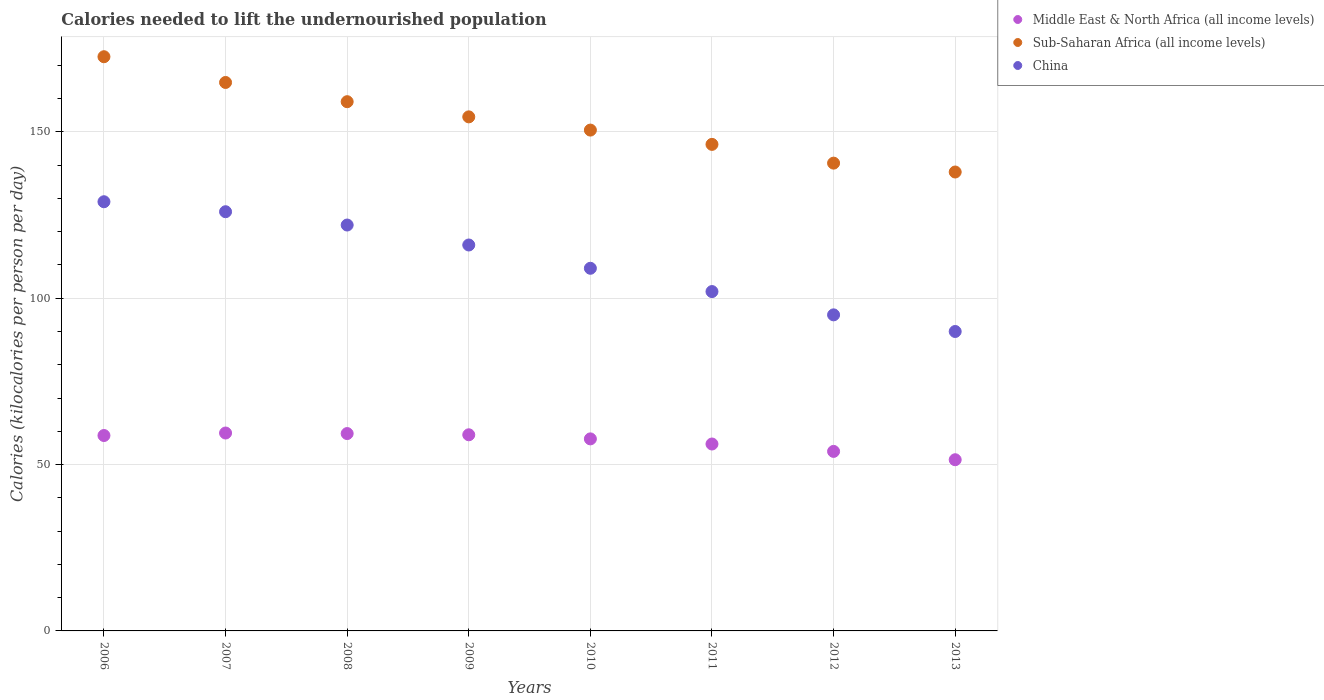How many different coloured dotlines are there?
Provide a short and direct response. 3. What is the total calories needed to lift the undernourished population in Sub-Saharan Africa (all income levels) in 2009?
Keep it short and to the point. 154.51. Across all years, what is the maximum total calories needed to lift the undernourished population in China?
Give a very brief answer. 129. Across all years, what is the minimum total calories needed to lift the undernourished population in Sub-Saharan Africa (all income levels)?
Offer a very short reply. 137.94. In which year was the total calories needed to lift the undernourished population in China maximum?
Provide a succinct answer. 2006. In which year was the total calories needed to lift the undernourished population in Middle East & North Africa (all income levels) minimum?
Your answer should be very brief. 2013. What is the total total calories needed to lift the undernourished population in Middle East & North Africa (all income levels) in the graph?
Ensure brevity in your answer.  455.81. What is the difference between the total calories needed to lift the undernourished population in Middle East & North Africa (all income levels) in 2007 and that in 2012?
Provide a short and direct response. 5.52. What is the difference between the total calories needed to lift the undernourished population in Middle East & North Africa (all income levels) in 2011 and the total calories needed to lift the undernourished population in Sub-Saharan Africa (all income levels) in 2012?
Give a very brief answer. -84.42. What is the average total calories needed to lift the undernourished population in Middle East & North Africa (all income levels) per year?
Your answer should be compact. 56.98. In the year 2011, what is the difference between the total calories needed to lift the undernourished population in Middle East & North Africa (all income levels) and total calories needed to lift the undernourished population in Sub-Saharan Africa (all income levels)?
Offer a very short reply. -90.06. In how many years, is the total calories needed to lift the undernourished population in Middle East & North Africa (all income levels) greater than 140 kilocalories?
Make the answer very short. 0. What is the ratio of the total calories needed to lift the undernourished population in China in 2007 to that in 2012?
Make the answer very short. 1.33. Is the total calories needed to lift the undernourished population in Sub-Saharan Africa (all income levels) in 2007 less than that in 2013?
Offer a very short reply. No. What is the difference between the highest and the second highest total calories needed to lift the undernourished population in Middle East & North Africa (all income levels)?
Your answer should be compact. 0.16. What is the difference between the highest and the lowest total calories needed to lift the undernourished population in China?
Ensure brevity in your answer.  39. In how many years, is the total calories needed to lift the undernourished population in Sub-Saharan Africa (all income levels) greater than the average total calories needed to lift the undernourished population in Sub-Saharan Africa (all income levels) taken over all years?
Ensure brevity in your answer.  4. Is the sum of the total calories needed to lift the undernourished population in Sub-Saharan Africa (all income levels) in 2006 and 2007 greater than the maximum total calories needed to lift the undernourished population in China across all years?
Your answer should be very brief. Yes. Does the total calories needed to lift the undernourished population in Sub-Saharan Africa (all income levels) monotonically increase over the years?
Keep it short and to the point. No. Does the graph contain grids?
Your answer should be very brief. Yes. How are the legend labels stacked?
Offer a terse response. Vertical. What is the title of the graph?
Ensure brevity in your answer.  Calories needed to lift the undernourished population. Does "Belgium" appear as one of the legend labels in the graph?
Your answer should be compact. No. What is the label or title of the X-axis?
Provide a succinct answer. Years. What is the label or title of the Y-axis?
Provide a short and direct response. Calories (kilocalories per person per day). What is the Calories (kilocalories per person per day) in Middle East & North Africa (all income levels) in 2006?
Your response must be concise. 58.73. What is the Calories (kilocalories per person per day) of Sub-Saharan Africa (all income levels) in 2006?
Ensure brevity in your answer.  172.59. What is the Calories (kilocalories per person per day) in China in 2006?
Your answer should be compact. 129. What is the Calories (kilocalories per person per day) in Middle East & North Africa (all income levels) in 2007?
Give a very brief answer. 59.48. What is the Calories (kilocalories per person per day) in Sub-Saharan Africa (all income levels) in 2007?
Your answer should be compact. 164.85. What is the Calories (kilocalories per person per day) of China in 2007?
Keep it short and to the point. 126. What is the Calories (kilocalories per person per day) of Middle East & North Africa (all income levels) in 2008?
Ensure brevity in your answer.  59.32. What is the Calories (kilocalories per person per day) in Sub-Saharan Africa (all income levels) in 2008?
Your answer should be compact. 159.07. What is the Calories (kilocalories per person per day) of China in 2008?
Offer a terse response. 122. What is the Calories (kilocalories per person per day) of Middle East & North Africa (all income levels) in 2009?
Provide a succinct answer. 58.95. What is the Calories (kilocalories per person per day) of Sub-Saharan Africa (all income levels) in 2009?
Your response must be concise. 154.51. What is the Calories (kilocalories per person per day) in China in 2009?
Your answer should be compact. 116. What is the Calories (kilocalories per person per day) in Middle East & North Africa (all income levels) in 2010?
Your answer should be very brief. 57.72. What is the Calories (kilocalories per person per day) in Sub-Saharan Africa (all income levels) in 2010?
Ensure brevity in your answer.  150.54. What is the Calories (kilocalories per person per day) in China in 2010?
Your answer should be very brief. 109. What is the Calories (kilocalories per person per day) of Middle East & North Africa (all income levels) in 2011?
Offer a very short reply. 56.18. What is the Calories (kilocalories per person per day) of Sub-Saharan Africa (all income levels) in 2011?
Offer a very short reply. 146.24. What is the Calories (kilocalories per person per day) of China in 2011?
Give a very brief answer. 102. What is the Calories (kilocalories per person per day) in Middle East & North Africa (all income levels) in 2012?
Provide a short and direct response. 53.96. What is the Calories (kilocalories per person per day) of Sub-Saharan Africa (all income levels) in 2012?
Make the answer very short. 140.6. What is the Calories (kilocalories per person per day) in China in 2012?
Your answer should be compact. 95. What is the Calories (kilocalories per person per day) of Middle East & North Africa (all income levels) in 2013?
Your response must be concise. 51.45. What is the Calories (kilocalories per person per day) of Sub-Saharan Africa (all income levels) in 2013?
Provide a succinct answer. 137.94. Across all years, what is the maximum Calories (kilocalories per person per day) in Middle East & North Africa (all income levels)?
Keep it short and to the point. 59.48. Across all years, what is the maximum Calories (kilocalories per person per day) in Sub-Saharan Africa (all income levels)?
Your response must be concise. 172.59. Across all years, what is the maximum Calories (kilocalories per person per day) of China?
Provide a short and direct response. 129. Across all years, what is the minimum Calories (kilocalories per person per day) of Middle East & North Africa (all income levels)?
Offer a terse response. 51.45. Across all years, what is the minimum Calories (kilocalories per person per day) in Sub-Saharan Africa (all income levels)?
Offer a very short reply. 137.94. What is the total Calories (kilocalories per person per day) of Middle East & North Africa (all income levels) in the graph?
Keep it short and to the point. 455.81. What is the total Calories (kilocalories per person per day) in Sub-Saharan Africa (all income levels) in the graph?
Your response must be concise. 1226.33. What is the total Calories (kilocalories per person per day) of China in the graph?
Your answer should be compact. 889. What is the difference between the Calories (kilocalories per person per day) in Middle East & North Africa (all income levels) in 2006 and that in 2007?
Your response must be concise. -0.75. What is the difference between the Calories (kilocalories per person per day) of Sub-Saharan Africa (all income levels) in 2006 and that in 2007?
Make the answer very short. 7.74. What is the difference between the Calories (kilocalories per person per day) of China in 2006 and that in 2007?
Keep it short and to the point. 3. What is the difference between the Calories (kilocalories per person per day) in Middle East & North Africa (all income levels) in 2006 and that in 2008?
Provide a short and direct response. -0.59. What is the difference between the Calories (kilocalories per person per day) in Sub-Saharan Africa (all income levels) in 2006 and that in 2008?
Make the answer very short. 13.52. What is the difference between the Calories (kilocalories per person per day) of Middle East & North Africa (all income levels) in 2006 and that in 2009?
Give a very brief answer. -0.22. What is the difference between the Calories (kilocalories per person per day) in Sub-Saharan Africa (all income levels) in 2006 and that in 2009?
Ensure brevity in your answer.  18.08. What is the difference between the Calories (kilocalories per person per day) of Middle East & North Africa (all income levels) in 2006 and that in 2010?
Ensure brevity in your answer.  1.01. What is the difference between the Calories (kilocalories per person per day) in Sub-Saharan Africa (all income levels) in 2006 and that in 2010?
Offer a terse response. 22.05. What is the difference between the Calories (kilocalories per person per day) in China in 2006 and that in 2010?
Keep it short and to the point. 20. What is the difference between the Calories (kilocalories per person per day) in Middle East & North Africa (all income levels) in 2006 and that in 2011?
Provide a succinct answer. 2.55. What is the difference between the Calories (kilocalories per person per day) in Sub-Saharan Africa (all income levels) in 2006 and that in 2011?
Provide a short and direct response. 26.35. What is the difference between the Calories (kilocalories per person per day) of China in 2006 and that in 2011?
Offer a very short reply. 27. What is the difference between the Calories (kilocalories per person per day) of Middle East & North Africa (all income levels) in 2006 and that in 2012?
Make the answer very short. 4.77. What is the difference between the Calories (kilocalories per person per day) of Sub-Saharan Africa (all income levels) in 2006 and that in 2012?
Give a very brief answer. 31.98. What is the difference between the Calories (kilocalories per person per day) in China in 2006 and that in 2012?
Give a very brief answer. 34. What is the difference between the Calories (kilocalories per person per day) of Middle East & North Africa (all income levels) in 2006 and that in 2013?
Provide a succinct answer. 7.28. What is the difference between the Calories (kilocalories per person per day) in Sub-Saharan Africa (all income levels) in 2006 and that in 2013?
Your answer should be very brief. 34.65. What is the difference between the Calories (kilocalories per person per day) of China in 2006 and that in 2013?
Offer a terse response. 39. What is the difference between the Calories (kilocalories per person per day) of Middle East & North Africa (all income levels) in 2007 and that in 2008?
Make the answer very short. 0.16. What is the difference between the Calories (kilocalories per person per day) of Sub-Saharan Africa (all income levels) in 2007 and that in 2008?
Keep it short and to the point. 5.78. What is the difference between the Calories (kilocalories per person per day) in Middle East & North Africa (all income levels) in 2007 and that in 2009?
Offer a terse response. 0.53. What is the difference between the Calories (kilocalories per person per day) of Sub-Saharan Africa (all income levels) in 2007 and that in 2009?
Offer a very short reply. 10.34. What is the difference between the Calories (kilocalories per person per day) in China in 2007 and that in 2009?
Your response must be concise. 10. What is the difference between the Calories (kilocalories per person per day) in Middle East & North Africa (all income levels) in 2007 and that in 2010?
Offer a terse response. 1.76. What is the difference between the Calories (kilocalories per person per day) of Sub-Saharan Africa (all income levels) in 2007 and that in 2010?
Make the answer very short. 14.31. What is the difference between the Calories (kilocalories per person per day) in China in 2007 and that in 2010?
Provide a succinct answer. 17. What is the difference between the Calories (kilocalories per person per day) of Middle East & North Africa (all income levels) in 2007 and that in 2011?
Your response must be concise. 3.3. What is the difference between the Calories (kilocalories per person per day) in Sub-Saharan Africa (all income levels) in 2007 and that in 2011?
Offer a very short reply. 18.61. What is the difference between the Calories (kilocalories per person per day) of China in 2007 and that in 2011?
Your answer should be compact. 24. What is the difference between the Calories (kilocalories per person per day) of Middle East & North Africa (all income levels) in 2007 and that in 2012?
Make the answer very short. 5.53. What is the difference between the Calories (kilocalories per person per day) in Sub-Saharan Africa (all income levels) in 2007 and that in 2012?
Offer a very short reply. 24.25. What is the difference between the Calories (kilocalories per person per day) of Middle East & North Africa (all income levels) in 2007 and that in 2013?
Make the answer very short. 8.03. What is the difference between the Calories (kilocalories per person per day) in Sub-Saharan Africa (all income levels) in 2007 and that in 2013?
Give a very brief answer. 26.91. What is the difference between the Calories (kilocalories per person per day) of Middle East & North Africa (all income levels) in 2008 and that in 2009?
Your response must be concise. 0.37. What is the difference between the Calories (kilocalories per person per day) of Sub-Saharan Africa (all income levels) in 2008 and that in 2009?
Ensure brevity in your answer.  4.56. What is the difference between the Calories (kilocalories per person per day) of Middle East & North Africa (all income levels) in 2008 and that in 2010?
Offer a terse response. 1.6. What is the difference between the Calories (kilocalories per person per day) of Sub-Saharan Africa (all income levels) in 2008 and that in 2010?
Provide a short and direct response. 8.54. What is the difference between the Calories (kilocalories per person per day) in China in 2008 and that in 2010?
Your response must be concise. 13. What is the difference between the Calories (kilocalories per person per day) in Middle East & North Africa (all income levels) in 2008 and that in 2011?
Make the answer very short. 3.14. What is the difference between the Calories (kilocalories per person per day) in Sub-Saharan Africa (all income levels) in 2008 and that in 2011?
Offer a very short reply. 12.83. What is the difference between the Calories (kilocalories per person per day) of China in 2008 and that in 2011?
Your response must be concise. 20. What is the difference between the Calories (kilocalories per person per day) of Middle East & North Africa (all income levels) in 2008 and that in 2012?
Ensure brevity in your answer.  5.36. What is the difference between the Calories (kilocalories per person per day) in Sub-Saharan Africa (all income levels) in 2008 and that in 2012?
Provide a succinct answer. 18.47. What is the difference between the Calories (kilocalories per person per day) of China in 2008 and that in 2012?
Your response must be concise. 27. What is the difference between the Calories (kilocalories per person per day) in Middle East & North Africa (all income levels) in 2008 and that in 2013?
Offer a very short reply. 7.87. What is the difference between the Calories (kilocalories per person per day) in Sub-Saharan Africa (all income levels) in 2008 and that in 2013?
Ensure brevity in your answer.  21.14. What is the difference between the Calories (kilocalories per person per day) in China in 2008 and that in 2013?
Provide a succinct answer. 32. What is the difference between the Calories (kilocalories per person per day) of Middle East & North Africa (all income levels) in 2009 and that in 2010?
Make the answer very short. 1.23. What is the difference between the Calories (kilocalories per person per day) in Sub-Saharan Africa (all income levels) in 2009 and that in 2010?
Keep it short and to the point. 3.97. What is the difference between the Calories (kilocalories per person per day) of Middle East & North Africa (all income levels) in 2009 and that in 2011?
Offer a terse response. 2.77. What is the difference between the Calories (kilocalories per person per day) in Sub-Saharan Africa (all income levels) in 2009 and that in 2011?
Your answer should be very brief. 8.27. What is the difference between the Calories (kilocalories per person per day) in China in 2009 and that in 2011?
Your answer should be very brief. 14. What is the difference between the Calories (kilocalories per person per day) in Middle East & North Africa (all income levels) in 2009 and that in 2012?
Your answer should be compact. 5. What is the difference between the Calories (kilocalories per person per day) in Sub-Saharan Africa (all income levels) in 2009 and that in 2012?
Offer a terse response. 13.91. What is the difference between the Calories (kilocalories per person per day) in China in 2009 and that in 2012?
Your answer should be very brief. 21. What is the difference between the Calories (kilocalories per person per day) in Middle East & North Africa (all income levels) in 2009 and that in 2013?
Your answer should be compact. 7.5. What is the difference between the Calories (kilocalories per person per day) of Sub-Saharan Africa (all income levels) in 2009 and that in 2013?
Your answer should be very brief. 16.58. What is the difference between the Calories (kilocalories per person per day) of Middle East & North Africa (all income levels) in 2010 and that in 2011?
Ensure brevity in your answer.  1.54. What is the difference between the Calories (kilocalories per person per day) in Sub-Saharan Africa (all income levels) in 2010 and that in 2011?
Your answer should be compact. 4.3. What is the difference between the Calories (kilocalories per person per day) in Middle East & North Africa (all income levels) in 2010 and that in 2012?
Keep it short and to the point. 3.76. What is the difference between the Calories (kilocalories per person per day) of Sub-Saharan Africa (all income levels) in 2010 and that in 2012?
Offer a very short reply. 9.93. What is the difference between the Calories (kilocalories per person per day) in Middle East & North Africa (all income levels) in 2010 and that in 2013?
Make the answer very short. 6.27. What is the difference between the Calories (kilocalories per person per day) in Sub-Saharan Africa (all income levels) in 2010 and that in 2013?
Your response must be concise. 12.6. What is the difference between the Calories (kilocalories per person per day) of Middle East & North Africa (all income levels) in 2011 and that in 2012?
Give a very brief answer. 2.22. What is the difference between the Calories (kilocalories per person per day) of Sub-Saharan Africa (all income levels) in 2011 and that in 2012?
Your answer should be very brief. 5.64. What is the difference between the Calories (kilocalories per person per day) in Middle East & North Africa (all income levels) in 2011 and that in 2013?
Give a very brief answer. 4.73. What is the difference between the Calories (kilocalories per person per day) of Sub-Saharan Africa (all income levels) in 2011 and that in 2013?
Make the answer very short. 8.31. What is the difference between the Calories (kilocalories per person per day) in China in 2011 and that in 2013?
Your response must be concise. 12. What is the difference between the Calories (kilocalories per person per day) in Middle East & North Africa (all income levels) in 2012 and that in 2013?
Keep it short and to the point. 2.5. What is the difference between the Calories (kilocalories per person per day) in Sub-Saharan Africa (all income levels) in 2012 and that in 2013?
Keep it short and to the point. 2.67. What is the difference between the Calories (kilocalories per person per day) in Middle East & North Africa (all income levels) in 2006 and the Calories (kilocalories per person per day) in Sub-Saharan Africa (all income levels) in 2007?
Keep it short and to the point. -106.12. What is the difference between the Calories (kilocalories per person per day) in Middle East & North Africa (all income levels) in 2006 and the Calories (kilocalories per person per day) in China in 2007?
Your response must be concise. -67.27. What is the difference between the Calories (kilocalories per person per day) in Sub-Saharan Africa (all income levels) in 2006 and the Calories (kilocalories per person per day) in China in 2007?
Offer a very short reply. 46.59. What is the difference between the Calories (kilocalories per person per day) in Middle East & North Africa (all income levels) in 2006 and the Calories (kilocalories per person per day) in Sub-Saharan Africa (all income levels) in 2008?
Provide a succinct answer. -100.34. What is the difference between the Calories (kilocalories per person per day) of Middle East & North Africa (all income levels) in 2006 and the Calories (kilocalories per person per day) of China in 2008?
Give a very brief answer. -63.27. What is the difference between the Calories (kilocalories per person per day) in Sub-Saharan Africa (all income levels) in 2006 and the Calories (kilocalories per person per day) in China in 2008?
Ensure brevity in your answer.  50.59. What is the difference between the Calories (kilocalories per person per day) of Middle East & North Africa (all income levels) in 2006 and the Calories (kilocalories per person per day) of Sub-Saharan Africa (all income levels) in 2009?
Your answer should be very brief. -95.78. What is the difference between the Calories (kilocalories per person per day) in Middle East & North Africa (all income levels) in 2006 and the Calories (kilocalories per person per day) in China in 2009?
Make the answer very short. -57.27. What is the difference between the Calories (kilocalories per person per day) in Sub-Saharan Africa (all income levels) in 2006 and the Calories (kilocalories per person per day) in China in 2009?
Keep it short and to the point. 56.59. What is the difference between the Calories (kilocalories per person per day) of Middle East & North Africa (all income levels) in 2006 and the Calories (kilocalories per person per day) of Sub-Saharan Africa (all income levels) in 2010?
Keep it short and to the point. -91.8. What is the difference between the Calories (kilocalories per person per day) in Middle East & North Africa (all income levels) in 2006 and the Calories (kilocalories per person per day) in China in 2010?
Keep it short and to the point. -50.27. What is the difference between the Calories (kilocalories per person per day) of Sub-Saharan Africa (all income levels) in 2006 and the Calories (kilocalories per person per day) of China in 2010?
Your answer should be very brief. 63.59. What is the difference between the Calories (kilocalories per person per day) in Middle East & North Africa (all income levels) in 2006 and the Calories (kilocalories per person per day) in Sub-Saharan Africa (all income levels) in 2011?
Ensure brevity in your answer.  -87.51. What is the difference between the Calories (kilocalories per person per day) in Middle East & North Africa (all income levels) in 2006 and the Calories (kilocalories per person per day) in China in 2011?
Ensure brevity in your answer.  -43.27. What is the difference between the Calories (kilocalories per person per day) in Sub-Saharan Africa (all income levels) in 2006 and the Calories (kilocalories per person per day) in China in 2011?
Your answer should be very brief. 70.59. What is the difference between the Calories (kilocalories per person per day) in Middle East & North Africa (all income levels) in 2006 and the Calories (kilocalories per person per day) in Sub-Saharan Africa (all income levels) in 2012?
Provide a short and direct response. -81.87. What is the difference between the Calories (kilocalories per person per day) in Middle East & North Africa (all income levels) in 2006 and the Calories (kilocalories per person per day) in China in 2012?
Provide a short and direct response. -36.27. What is the difference between the Calories (kilocalories per person per day) of Sub-Saharan Africa (all income levels) in 2006 and the Calories (kilocalories per person per day) of China in 2012?
Make the answer very short. 77.59. What is the difference between the Calories (kilocalories per person per day) in Middle East & North Africa (all income levels) in 2006 and the Calories (kilocalories per person per day) in Sub-Saharan Africa (all income levels) in 2013?
Your answer should be compact. -79.2. What is the difference between the Calories (kilocalories per person per day) in Middle East & North Africa (all income levels) in 2006 and the Calories (kilocalories per person per day) in China in 2013?
Make the answer very short. -31.27. What is the difference between the Calories (kilocalories per person per day) of Sub-Saharan Africa (all income levels) in 2006 and the Calories (kilocalories per person per day) of China in 2013?
Keep it short and to the point. 82.59. What is the difference between the Calories (kilocalories per person per day) of Middle East & North Africa (all income levels) in 2007 and the Calories (kilocalories per person per day) of Sub-Saharan Africa (all income levels) in 2008?
Offer a terse response. -99.59. What is the difference between the Calories (kilocalories per person per day) in Middle East & North Africa (all income levels) in 2007 and the Calories (kilocalories per person per day) in China in 2008?
Keep it short and to the point. -62.52. What is the difference between the Calories (kilocalories per person per day) in Sub-Saharan Africa (all income levels) in 2007 and the Calories (kilocalories per person per day) in China in 2008?
Provide a short and direct response. 42.85. What is the difference between the Calories (kilocalories per person per day) of Middle East & North Africa (all income levels) in 2007 and the Calories (kilocalories per person per day) of Sub-Saharan Africa (all income levels) in 2009?
Keep it short and to the point. -95.03. What is the difference between the Calories (kilocalories per person per day) of Middle East & North Africa (all income levels) in 2007 and the Calories (kilocalories per person per day) of China in 2009?
Your answer should be very brief. -56.52. What is the difference between the Calories (kilocalories per person per day) in Sub-Saharan Africa (all income levels) in 2007 and the Calories (kilocalories per person per day) in China in 2009?
Keep it short and to the point. 48.85. What is the difference between the Calories (kilocalories per person per day) in Middle East & North Africa (all income levels) in 2007 and the Calories (kilocalories per person per day) in Sub-Saharan Africa (all income levels) in 2010?
Provide a short and direct response. -91.05. What is the difference between the Calories (kilocalories per person per day) of Middle East & North Africa (all income levels) in 2007 and the Calories (kilocalories per person per day) of China in 2010?
Keep it short and to the point. -49.52. What is the difference between the Calories (kilocalories per person per day) of Sub-Saharan Africa (all income levels) in 2007 and the Calories (kilocalories per person per day) of China in 2010?
Keep it short and to the point. 55.85. What is the difference between the Calories (kilocalories per person per day) in Middle East & North Africa (all income levels) in 2007 and the Calories (kilocalories per person per day) in Sub-Saharan Africa (all income levels) in 2011?
Your response must be concise. -86.76. What is the difference between the Calories (kilocalories per person per day) of Middle East & North Africa (all income levels) in 2007 and the Calories (kilocalories per person per day) of China in 2011?
Provide a succinct answer. -42.52. What is the difference between the Calories (kilocalories per person per day) of Sub-Saharan Africa (all income levels) in 2007 and the Calories (kilocalories per person per day) of China in 2011?
Provide a short and direct response. 62.85. What is the difference between the Calories (kilocalories per person per day) in Middle East & North Africa (all income levels) in 2007 and the Calories (kilocalories per person per day) in Sub-Saharan Africa (all income levels) in 2012?
Offer a terse response. -81.12. What is the difference between the Calories (kilocalories per person per day) of Middle East & North Africa (all income levels) in 2007 and the Calories (kilocalories per person per day) of China in 2012?
Keep it short and to the point. -35.52. What is the difference between the Calories (kilocalories per person per day) of Sub-Saharan Africa (all income levels) in 2007 and the Calories (kilocalories per person per day) of China in 2012?
Provide a short and direct response. 69.85. What is the difference between the Calories (kilocalories per person per day) in Middle East & North Africa (all income levels) in 2007 and the Calories (kilocalories per person per day) in Sub-Saharan Africa (all income levels) in 2013?
Keep it short and to the point. -78.45. What is the difference between the Calories (kilocalories per person per day) in Middle East & North Africa (all income levels) in 2007 and the Calories (kilocalories per person per day) in China in 2013?
Keep it short and to the point. -30.52. What is the difference between the Calories (kilocalories per person per day) in Sub-Saharan Africa (all income levels) in 2007 and the Calories (kilocalories per person per day) in China in 2013?
Offer a terse response. 74.85. What is the difference between the Calories (kilocalories per person per day) of Middle East & North Africa (all income levels) in 2008 and the Calories (kilocalories per person per day) of Sub-Saharan Africa (all income levels) in 2009?
Offer a very short reply. -95.19. What is the difference between the Calories (kilocalories per person per day) in Middle East & North Africa (all income levels) in 2008 and the Calories (kilocalories per person per day) in China in 2009?
Provide a short and direct response. -56.68. What is the difference between the Calories (kilocalories per person per day) in Sub-Saharan Africa (all income levels) in 2008 and the Calories (kilocalories per person per day) in China in 2009?
Give a very brief answer. 43.07. What is the difference between the Calories (kilocalories per person per day) in Middle East & North Africa (all income levels) in 2008 and the Calories (kilocalories per person per day) in Sub-Saharan Africa (all income levels) in 2010?
Provide a succinct answer. -91.21. What is the difference between the Calories (kilocalories per person per day) in Middle East & North Africa (all income levels) in 2008 and the Calories (kilocalories per person per day) in China in 2010?
Your response must be concise. -49.68. What is the difference between the Calories (kilocalories per person per day) in Sub-Saharan Africa (all income levels) in 2008 and the Calories (kilocalories per person per day) in China in 2010?
Make the answer very short. 50.07. What is the difference between the Calories (kilocalories per person per day) in Middle East & North Africa (all income levels) in 2008 and the Calories (kilocalories per person per day) in Sub-Saharan Africa (all income levels) in 2011?
Your answer should be compact. -86.92. What is the difference between the Calories (kilocalories per person per day) in Middle East & North Africa (all income levels) in 2008 and the Calories (kilocalories per person per day) in China in 2011?
Provide a succinct answer. -42.68. What is the difference between the Calories (kilocalories per person per day) of Sub-Saharan Africa (all income levels) in 2008 and the Calories (kilocalories per person per day) of China in 2011?
Ensure brevity in your answer.  57.07. What is the difference between the Calories (kilocalories per person per day) in Middle East & North Africa (all income levels) in 2008 and the Calories (kilocalories per person per day) in Sub-Saharan Africa (all income levels) in 2012?
Make the answer very short. -81.28. What is the difference between the Calories (kilocalories per person per day) in Middle East & North Africa (all income levels) in 2008 and the Calories (kilocalories per person per day) in China in 2012?
Give a very brief answer. -35.68. What is the difference between the Calories (kilocalories per person per day) of Sub-Saharan Africa (all income levels) in 2008 and the Calories (kilocalories per person per day) of China in 2012?
Your response must be concise. 64.07. What is the difference between the Calories (kilocalories per person per day) of Middle East & North Africa (all income levels) in 2008 and the Calories (kilocalories per person per day) of Sub-Saharan Africa (all income levels) in 2013?
Provide a succinct answer. -78.61. What is the difference between the Calories (kilocalories per person per day) of Middle East & North Africa (all income levels) in 2008 and the Calories (kilocalories per person per day) of China in 2013?
Provide a short and direct response. -30.68. What is the difference between the Calories (kilocalories per person per day) in Sub-Saharan Africa (all income levels) in 2008 and the Calories (kilocalories per person per day) in China in 2013?
Keep it short and to the point. 69.07. What is the difference between the Calories (kilocalories per person per day) in Middle East & North Africa (all income levels) in 2009 and the Calories (kilocalories per person per day) in Sub-Saharan Africa (all income levels) in 2010?
Make the answer very short. -91.58. What is the difference between the Calories (kilocalories per person per day) of Middle East & North Africa (all income levels) in 2009 and the Calories (kilocalories per person per day) of China in 2010?
Ensure brevity in your answer.  -50.05. What is the difference between the Calories (kilocalories per person per day) in Sub-Saharan Africa (all income levels) in 2009 and the Calories (kilocalories per person per day) in China in 2010?
Offer a very short reply. 45.51. What is the difference between the Calories (kilocalories per person per day) of Middle East & North Africa (all income levels) in 2009 and the Calories (kilocalories per person per day) of Sub-Saharan Africa (all income levels) in 2011?
Keep it short and to the point. -87.29. What is the difference between the Calories (kilocalories per person per day) in Middle East & North Africa (all income levels) in 2009 and the Calories (kilocalories per person per day) in China in 2011?
Give a very brief answer. -43.05. What is the difference between the Calories (kilocalories per person per day) of Sub-Saharan Africa (all income levels) in 2009 and the Calories (kilocalories per person per day) of China in 2011?
Keep it short and to the point. 52.51. What is the difference between the Calories (kilocalories per person per day) in Middle East & North Africa (all income levels) in 2009 and the Calories (kilocalories per person per day) in Sub-Saharan Africa (all income levels) in 2012?
Your response must be concise. -81.65. What is the difference between the Calories (kilocalories per person per day) in Middle East & North Africa (all income levels) in 2009 and the Calories (kilocalories per person per day) in China in 2012?
Provide a short and direct response. -36.05. What is the difference between the Calories (kilocalories per person per day) of Sub-Saharan Africa (all income levels) in 2009 and the Calories (kilocalories per person per day) of China in 2012?
Ensure brevity in your answer.  59.51. What is the difference between the Calories (kilocalories per person per day) in Middle East & North Africa (all income levels) in 2009 and the Calories (kilocalories per person per day) in Sub-Saharan Africa (all income levels) in 2013?
Give a very brief answer. -78.98. What is the difference between the Calories (kilocalories per person per day) in Middle East & North Africa (all income levels) in 2009 and the Calories (kilocalories per person per day) in China in 2013?
Offer a very short reply. -31.05. What is the difference between the Calories (kilocalories per person per day) of Sub-Saharan Africa (all income levels) in 2009 and the Calories (kilocalories per person per day) of China in 2013?
Offer a very short reply. 64.51. What is the difference between the Calories (kilocalories per person per day) of Middle East & North Africa (all income levels) in 2010 and the Calories (kilocalories per person per day) of Sub-Saharan Africa (all income levels) in 2011?
Offer a terse response. -88.52. What is the difference between the Calories (kilocalories per person per day) in Middle East & North Africa (all income levels) in 2010 and the Calories (kilocalories per person per day) in China in 2011?
Make the answer very short. -44.28. What is the difference between the Calories (kilocalories per person per day) in Sub-Saharan Africa (all income levels) in 2010 and the Calories (kilocalories per person per day) in China in 2011?
Ensure brevity in your answer.  48.54. What is the difference between the Calories (kilocalories per person per day) in Middle East & North Africa (all income levels) in 2010 and the Calories (kilocalories per person per day) in Sub-Saharan Africa (all income levels) in 2012?
Give a very brief answer. -82.88. What is the difference between the Calories (kilocalories per person per day) in Middle East & North Africa (all income levels) in 2010 and the Calories (kilocalories per person per day) in China in 2012?
Give a very brief answer. -37.28. What is the difference between the Calories (kilocalories per person per day) in Sub-Saharan Africa (all income levels) in 2010 and the Calories (kilocalories per person per day) in China in 2012?
Provide a succinct answer. 55.54. What is the difference between the Calories (kilocalories per person per day) of Middle East & North Africa (all income levels) in 2010 and the Calories (kilocalories per person per day) of Sub-Saharan Africa (all income levels) in 2013?
Your response must be concise. -80.21. What is the difference between the Calories (kilocalories per person per day) of Middle East & North Africa (all income levels) in 2010 and the Calories (kilocalories per person per day) of China in 2013?
Keep it short and to the point. -32.28. What is the difference between the Calories (kilocalories per person per day) of Sub-Saharan Africa (all income levels) in 2010 and the Calories (kilocalories per person per day) of China in 2013?
Offer a very short reply. 60.54. What is the difference between the Calories (kilocalories per person per day) in Middle East & North Africa (all income levels) in 2011 and the Calories (kilocalories per person per day) in Sub-Saharan Africa (all income levels) in 2012?
Your answer should be very brief. -84.42. What is the difference between the Calories (kilocalories per person per day) in Middle East & North Africa (all income levels) in 2011 and the Calories (kilocalories per person per day) in China in 2012?
Provide a short and direct response. -38.82. What is the difference between the Calories (kilocalories per person per day) in Sub-Saharan Africa (all income levels) in 2011 and the Calories (kilocalories per person per day) in China in 2012?
Offer a terse response. 51.24. What is the difference between the Calories (kilocalories per person per day) of Middle East & North Africa (all income levels) in 2011 and the Calories (kilocalories per person per day) of Sub-Saharan Africa (all income levels) in 2013?
Provide a short and direct response. -81.76. What is the difference between the Calories (kilocalories per person per day) in Middle East & North Africa (all income levels) in 2011 and the Calories (kilocalories per person per day) in China in 2013?
Make the answer very short. -33.82. What is the difference between the Calories (kilocalories per person per day) of Sub-Saharan Africa (all income levels) in 2011 and the Calories (kilocalories per person per day) of China in 2013?
Your answer should be compact. 56.24. What is the difference between the Calories (kilocalories per person per day) in Middle East & North Africa (all income levels) in 2012 and the Calories (kilocalories per person per day) in Sub-Saharan Africa (all income levels) in 2013?
Provide a succinct answer. -83.98. What is the difference between the Calories (kilocalories per person per day) in Middle East & North Africa (all income levels) in 2012 and the Calories (kilocalories per person per day) in China in 2013?
Ensure brevity in your answer.  -36.04. What is the difference between the Calories (kilocalories per person per day) in Sub-Saharan Africa (all income levels) in 2012 and the Calories (kilocalories per person per day) in China in 2013?
Keep it short and to the point. 50.6. What is the average Calories (kilocalories per person per day) in Middle East & North Africa (all income levels) per year?
Your answer should be very brief. 56.98. What is the average Calories (kilocalories per person per day) in Sub-Saharan Africa (all income levels) per year?
Make the answer very short. 153.29. What is the average Calories (kilocalories per person per day) in China per year?
Make the answer very short. 111.12. In the year 2006, what is the difference between the Calories (kilocalories per person per day) of Middle East & North Africa (all income levels) and Calories (kilocalories per person per day) of Sub-Saharan Africa (all income levels)?
Provide a short and direct response. -113.85. In the year 2006, what is the difference between the Calories (kilocalories per person per day) of Middle East & North Africa (all income levels) and Calories (kilocalories per person per day) of China?
Offer a very short reply. -70.27. In the year 2006, what is the difference between the Calories (kilocalories per person per day) of Sub-Saharan Africa (all income levels) and Calories (kilocalories per person per day) of China?
Provide a short and direct response. 43.59. In the year 2007, what is the difference between the Calories (kilocalories per person per day) in Middle East & North Africa (all income levels) and Calories (kilocalories per person per day) in Sub-Saharan Africa (all income levels)?
Your answer should be compact. -105.37. In the year 2007, what is the difference between the Calories (kilocalories per person per day) of Middle East & North Africa (all income levels) and Calories (kilocalories per person per day) of China?
Offer a terse response. -66.52. In the year 2007, what is the difference between the Calories (kilocalories per person per day) in Sub-Saharan Africa (all income levels) and Calories (kilocalories per person per day) in China?
Give a very brief answer. 38.85. In the year 2008, what is the difference between the Calories (kilocalories per person per day) of Middle East & North Africa (all income levels) and Calories (kilocalories per person per day) of Sub-Saharan Africa (all income levels)?
Keep it short and to the point. -99.75. In the year 2008, what is the difference between the Calories (kilocalories per person per day) of Middle East & North Africa (all income levels) and Calories (kilocalories per person per day) of China?
Your answer should be compact. -62.68. In the year 2008, what is the difference between the Calories (kilocalories per person per day) of Sub-Saharan Africa (all income levels) and Calories (kilocalories per person per day) of China?
Your answer should be compact. 37.07. In the year 2009, what is the difference between the Calories (kilocalories per person per day) in Middle East & North Africa (all income levels) and Calories (kilocalories per person per day) in Sub-Saharan Africa (all income levels)?
Your response must be concise. -95.56. In the year 2009, what is the difference between the Calories (kilocalories per person per day) in Middle East & North Africa (all income levels) and Calories (kilocalories per person per day) in China?
Your response must be concise. -57.05. In the year 2009, what is the difference between the Calories (kilocalories per person per day) of Sub-Saharan Africa (all income levels) and Calories (kilocalories per person per day) of China?
Ensure brevity in your answer.  38.51. In the year 2010, what is the difference between the Calories (kilocalories per person per day) in Middle East & North Africa (all income levels) and Calories (kilocalories per person per day) in Sub-Saharan Africa (all income levels)?
Your answer should be very brief. -92.81. In the year 2010, what is the difference between the Calories (kilocalories per person per day) in Middle East & North Africa (all income levels) and Calories (kilocalories per person per day) in China?
Your answer should be very brief. -51.28. In the year 2010, what is the difference between the Calories (kilocalories per person per day) in Sub-Saharan Africa (all income levels) and Calories (kilocalories per person per day) in China?
Ensure brevity in your answer.  41.54. In the year 2011, what is the difference between the Calories (kilocalories per person per day) of Middle East & North Africa (all income levels) and Calories (kilocalories per person per day) of Sub-Saharan Africa (all income levels)?
Provide a succinct answer. -90.06. In the year 2011, what is the difference between the Calories (kilocalories per person per day) of Middle East & North Africa (all income levels) and Calories (kilocalories per person per day) of China?
Make the answer very short. -45.82. In the year 2011, what is the difference between the Calories (kilocalories per person per day) of Sub-Saharan Africa (all income levels) and Calories (kilocalories per person per day) of China?
Provide a succinct answer. 44.24. In the year 2012, what is the difference between the Calories (kilocalories per person per day) of Middle East & North Africa (all income levels) and Calories (kilocalories per person per day) of Sub-Saharan Africa (all income levels)?
Your answer should be very brief. -86.64. In the year 2012, what is the difference between the Calories (kilocalories per person per day) in Middle East & North Africa (all income levels) and Calories (kilocalories per person per day) in China?
Your response must be concise. -41.04. In the year 2012, what is the difference between the Calories (kilocalories per person per day) in Sub-Saharan Africa (all income levels) and Calories (kilocalories per person per day) in China?
Provide a succinct answer. 45.6. In the year 2013, what is the difference between the Calories (kilocalories per person per day) of Middle East & North Africa (all income levels) and Calories (kilocalories per person per day) of Sub-Saharan Africa (all income levels)?
Give a very brief answer. -86.48. In the year 2013, what is the difference between the Calories (kilocalories per person per day) of Middle East & North Africa (all income levels) and Calories (kilocalories per person per day) of China?
Make the answer very short. -38.55. In the year 2013, what is the difference between the Calories (kilocalories per person per day) in Sub-Saharan Africa (all income levels) and Calories (kilocalories per person per day) in China?
Your response must be concise. 47.94. What is the ratio of the Calories (kilocalories per person per day) in Middle East & North Africa (all income levels) in 2006 to that in 2007?
Offer a terse response. 0.99. What is the ratio of the Calories (kilocalories per person per day) of Sub-Saharan Africa (all income levels) in 2006 to that in 2007?
Make the answer very short. 1.05. What is the ratio of the Calories (kilocalories per person per day) in China in 2006 to that in 2007?
Your answer should be compact. 1.02. What is the ratio of the Calories (kilocalories per person per day) of Middle East & North Africa (all income levels) in 2006 to that in 2008?
Make the answer very short. 0.99. What is the ratio of the Calories (kilocalories per person per day) of Sub-Saharan Africa (all income levels) in 2006 to that in 2008?
Give a very brief answer. 1.08. What is the ratio of the Calories (kilocalories per person per day) in China in 2006 to that in 2008?
Keep it short and to the point. 1.06. What is the ratio of the Calories (kilocalories per person per day) in Middle East & North Africa (all income levels) in 2006 to that in 2009?
Your response must be concise. 1. What is the ratio of the Calories (kilocalories per person per day) in Sub-Saharan Africa (all income levels) in 2006 to that in 2009?
Your answer should be very brief. 1.12. What is the ratio of the Calories (kilocalories per person per day) of China in 2006 to that in 2009?
Offer a very short reply. 1.11. What is the ratio of the Calories (kilocalories per person per day) in Middle East & North Africa (all income levels) in 2006 to that in 2010?
Make the answer very short. 1.02. What is the ratio of the Calories (kilocalories per person per day) in Sub-Saharan Africa (all income levels) in 2006 to that in 2010?
Keep it short and to the point. 1.15. What is the ratio of the Calories (kilocalories per person per day) of China in 2006 to that in 2010?
Your answer should be very brief. 1.18. What is the ratio of the Calories (kilocalories per person per day) of Middle East & North Africa (all income levels) in 2006 to that in 2011?
Your answer should be compact. 1.05. What is the ratio of the Calories (kilocalories per person per day) in Sub-Saharan Africa (all income levels) in 2006 to that in 2011?
Give a very brief answer. 1.18. What is the ratio of the Calories (kilocalories per person per day) in China in 2006 to that in 2011?
Your answer should be very brief. 1.26. What is the ratio of the Calories (kilocalories per person per day) of Middle East & North Africa (all income levels) in 2006 to that in 2012?
Keep it short and to the point. 1.09. What is the ratio of the Calories (kilocalories per person per day) in Sub-Saharan Africa (all income levels) in 2006 to that in 2012?
Offer a very short reply. 1.23. What is the ratio of the Calories (kilocalories per person per day) in China in 2006 to that in 2012?
Offer a terse response. 1.36. What is the ratio of the Calories (kilocalories per person per day) in Middle East & North Africa (all income levels) in 2006 to that in 2013?
Your response must be concise. 1.14. What is the ratio of the Calories (kilocalories per person per day) in Sub-Saharan Africa (all income levels) in 2006 to that in 2013?
Provide a succinct answer. 1.25. What is the ratio of the Calories (kilocalories per person per day) in China in 2006 to that in 2013?
Keep it short and to the point. 1.43. What is the ratio of the Calories (kilocalories per person per day) of Sub-Saharan Africa (all income levels) in 2007 to that in 2008?
Provide a succinct answer. 1.04. What is the ratio of the Calories (kilocalories per person per day) in China in 2007 to that in 2008?
Provide a short and direct response. 1.03. What is the ratio of the Calories (kilocalories per person per day) in Middle East & North Africa (all income levels) in 2007 to that in 2009?
Provide a succinct answer. 1.01. What is the ratio of the Calories (kilocalories per person per day) in Sub-Saharan Africa (all income levels) in 2007 to that in 2009?
Keep it short and to the point. 1.07. What is the ratio of the Calories (kilocalories per person per day) of China in 2007 to that in 2009?
Your answer should be very brief. 1.09. What is the ratio of the Calories (kilocalories per person per day) in Middle East & North Africa (all income levels) in 2007 to that in 2010?
Offer a very short reply. 1.03. What is the ratio of the Calories (kilocalories per person per day) in Sub-Saharan Africa (all income levels) in 2007 to that in 2010?
Ensure brevity in your answer.  1.1. What is the ratio of the Calories (kilocalories per person per day) in China in 2007 to that in 2010?
Provide a succinct answer. 1.16. What is the ratio of the Calories (kilocalories per person per day) of Middle East & North Africa (all income levels) in 2007 to that in 2011?
Make the answer very short. 1.06. What is the ratio of the Calories (kilocalories per person per day) in Sub-Saharan Africa (all income levels) in 2007 to that in 2011?
Offer a very short reply. 1.13. What is the ratio of the Calories (kilocalories per person per day) of China in 2007 to that in 2011?
Offer a very short reply. 1.24. What is the ratio of the Calories (kilocalories per person per day) of Middle East & North Africa (all income levels) in 2007 to that in 2012?
Offer a very short reply. 1.1. What is the ratio of the Calories (kilocalories per person per day) of Sub-Saharan Africa (all income levels) in 2007 to that in 2012?
Provide a short and direct response. 1.17. What is the ratio of the Calories (kilocalories per person per day) of China in 2007 to that in 2012?
Offer a terse response. 1.33. What is the ratio of the Calories (kilocalories per person per day) in Middle East & North Africa (all income levels) in 2007 to that in 2013?
Your response must be concise. 1.16. What is the ratio of the Calories (kilocalories per person per day) in Sub-Saharan Africa (all income levels) in 2007 to that in 2013?
Offer a terse response. 1.2. What is the ratio of the Calories (kilocalories per person per day) of Middle East & North Africa (all income levels) in 2008 to that in 2009?
Your answer should be compact. 1.01. What is the ratio of the Calories (kilocalories per person per day) in Sub-Saharan Africa (all income levels) in 2008 to that in 2009?
Offer a terse response. 1.03. What is the ratio of the Calories (kilocalories per person per day) in China in 2008 to that in 2009?
Your answer should be compact. 1.05. What is the ratio of the Calories (kilocalories per person per day) in Middle East & North Africa (all income levels) in 2008 to that in 2010?
Provide a short and direct response. 1.03. What is the ratio of the Calories (kilocalories per person per day) of Sub-Saharan Africa (all income levels) in 2008 to that in 2010?
Your answer should be very brief. 1.06. What is the ratio of the Calories (kilocalories per person per day) of China in 2008 to that in 2010?
Keep it short and to the point. 1.12. What is the ratio of the Calories (kilocalories per person per day) of Middle East & North Africa (all income levels) in 2008 to that in 2011?
Provide a succinct answer. 1.06. What is the ratio of the Calories (kilocalories per person per day) of Sub-Saharan Africa (all income levels) in 2008 to that in 2011?
Keep it short and to the point. 1.09. What is the ratio of the Calories (kilocalories per person per day) of China in 2008 to that in 2011?
Make the answer very short. 1.2. What is the ratio of the Calories (kilocalories per person per day) of Middle East & North Africa (all income levels) in 2008 to that in 2012?
Provide a succinct answer. 1.1. What is the ratio of the Calories (kilocalories per person per day) in Sub-Saharan Africa (all income levels) in 2008 to that in 2012?
Make the answer very short. 1.13. What is the ratio of the Calories (kilocalories per person per day) in China in 2008 to that in 2012?
Offer a very short reply. 1.28. What is the ratio of the Calories (kilocalories per person per day) of Middle East & North Africa (all income levels) in 2008 to that in 2013?
Your answer should be compact. 1.15. What is the ratio of the Calories (kilocalories per person per day) of Sub-Saharan Africa (all income levels) in 2008 to that in 2013?
Ensure brevity in your answer.  1.15. What is the ratio of the Calories (kilocalories per person per day) of China in 2008 to that in 2013?
Give a very brief answer. 1.36. What is the ratio of the Calories (kilocalories per person per day) of Middle East & North Africa (all income levels) in 2009 to that in 2010?
Keep it short and to the point. 1.02. What is the ratio of the Calories (kilocalories per person per day) of Sub-Saharan Africa (all income levels) in 2009 to that in 2010?
Offer a terse response. 1.03. What is the ratio of the Calories (kilocalories per person per day) of China in 2009 to that in 2010?
Provide a succinct answer. 1.06. What is the ratio of the Calories (kilocalories per person per day) of Middle East & North Africa (all income levels) in 2009 to that in 2011?
Offer a very short reply. 1.05. What is the ratio of the Calories (kilocalories per person per day) in Sub-Saharan Africa (all income levels) in 2009 to that in 2011?
Keep it short and to the point. 1.06. What is the ratio of the Calories (kilocalories per person per day) in China in 2009 to that in 2011?
Keep it short and to the point. 1.14. What is the ratio of the Calories (kilocalories per person per day) of Middle East & North Africa (all income levels) in 2009 to that in 2012?
Your answer should be compact. 1.09. What is the ratio of the Calories (kilocalories per person per day) of Sub-Saharan Africa (all income levels) in 2009 to that in 2012?
Your answer should be very brief. 1.1. What is the ratio of the Calories (kilocalories per person per day) in China in 2009 to that in 2012?
Your answer should be compact. 1.22. What is the ratio of the Calories (kilocalories per person per day) in Middle East & North Africa (all income levels) in 2009 to that in 2013?
Ensure brevity in your answer.  1.15. What is the ratio of the Calories (kilocalories per person per day) in Sub-Saharan Africa (all income levels) in 2009 to that in 2013?
Your response must be concise. 1.12. What is the ratio of the Calories (kilocalories per person per day) of China in 2009 to that in 2013?
Provide a short and direct response. 1.29. What is the ratio of the Calories (kilocalories per person per day) in Middle East & North Africa (all income levels) in 2010 to that in 2011?
Keep it short and to the point. 1.03. What is the ratio of the Calories (kilocalories per person per day) in Sub-Saharan Africa (all income levels) in 2010 to that in 2011?
Your answer should be very brief. 1.03. What is the ratio of the Calories (kilocalories per person per day) of China in 2010 to that in 2011?
Keep it short and to the point. 1.07. What is the ratio of the Calories (kilocalories per person per day) of Middle East & North Africa (all income levels) in 2010 to that in 2012?
Make the answer very short. 1.07. What is the ratio of the Calories (kilocalories per person per day) in Sub-Saharan Africa (all income levels) in 2010 to that in 2012?
Give a very brief answer. 1.07. What is the ratio of the Calories (kilocalories per person per day) in China in 2010 to that in 2012?
Provide a short and direct response. 1.15. What is the ratio of the Calories (kilocalories per person per day) in Middle East & North Africa (all income levels) in 2010 to that in 2013?
Provide a succinct answer. 1.12. What is the ratio of the Calories (kilocalories per person per day) of Sub-Saharan Africa (all income levels) in 2010 to that in 2013?
Your answer should be very brief. 1.09. What is the ratio of the Calories (kilocalories per person per day) in China in 2010 to that in 2013?
Your answer should be compact. 1.21. What is the ratio of the Calories (kilocalories per person per day) of Middle East & North Africa (all income levels) in 2011 to that in 2012?
Offer a terse response. 1.04. What is the ratio of the Calories (kilocalories per person per day) in Sub-Saharan Africa (all income levels) in 2011 to that in 2012?
Provide a succinct answer. 1.04. What is the ratio of the Calories (kilocalories per person per day) in China in 2011 to that in 2012?
Make the answer very short. 1.07. What is the ratio of the Calories (kilocalories per person per day) of Middle East & North Africa (all income levels) in 2011 to that in 2013?
Provide a short and direct response. 1.09. What is the ratio of the Calories (kilocalories per person per day) of Sub-Saharan Africa (all income levels) in 2011 to that in 2013?
Ensure brevity in your answer.  1.06. What is the ratio of the Calories (kilocalories per person per day) of China in 2011 to that in 2013?
Offer a very short reply. 1.13. What is the ratio of the Calories (kilocalories per person per day) in Middle East & North Africa (all income levels) in 2012 to that in 2013?
Your answer should be compact. 1.05. What is the ratio of the Calories (kilocalories per person per day) of Sub-Saharan Africa (all income levels) in 2012 to that in 2013?
Your response must be concise. 1.02. What is the ratio of the Calories (kilocalories per person per day) in China in 2012 to that in 2013?
Make the answer very short. 1.06. What is the difference between the highest and the second highest Calories (kilocalories per person per day) of Middle East & North Africa (all income levels)?
Your answer should be compact. 0.16. What is the difference between the highest and the second highest Calories (kilocalories per person per day) of Sub-Saharan Africa (all income levels)?
Your response must be concise. 7.74. What is the difference between the highest and the lowest Calories (kilocalories per person per day) in Middle East & North Africa (all income levels)?
Ensure brevity in your answer.  8.03. What is the difference between the highest and the lowest Calories (kilocalories per person per day) in Sub-Saharan Africa (all income levels)?
Keep it short and to the point. 34.65. What is the difference between the highest and the lowest Calories (kilocalories per person per day) in China?
Keep it short and to the point. 39. 